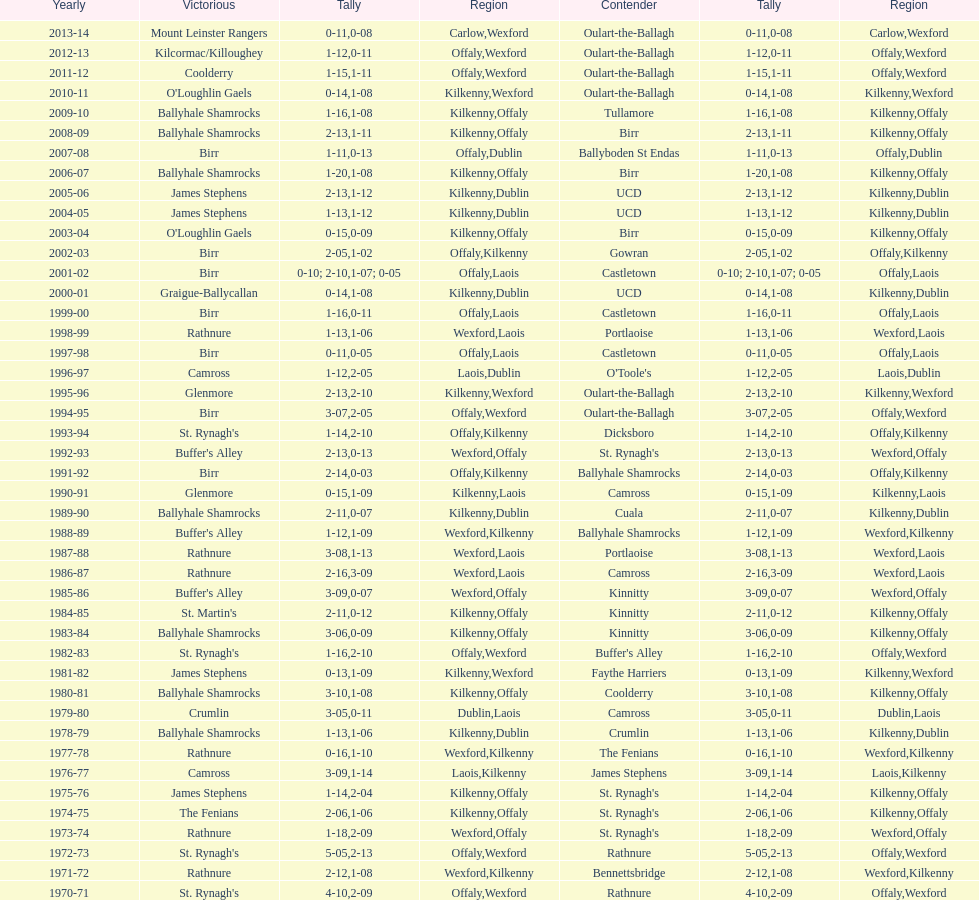Which winner is next to mount leinster rangers? Kilcormac/Killoughey. 